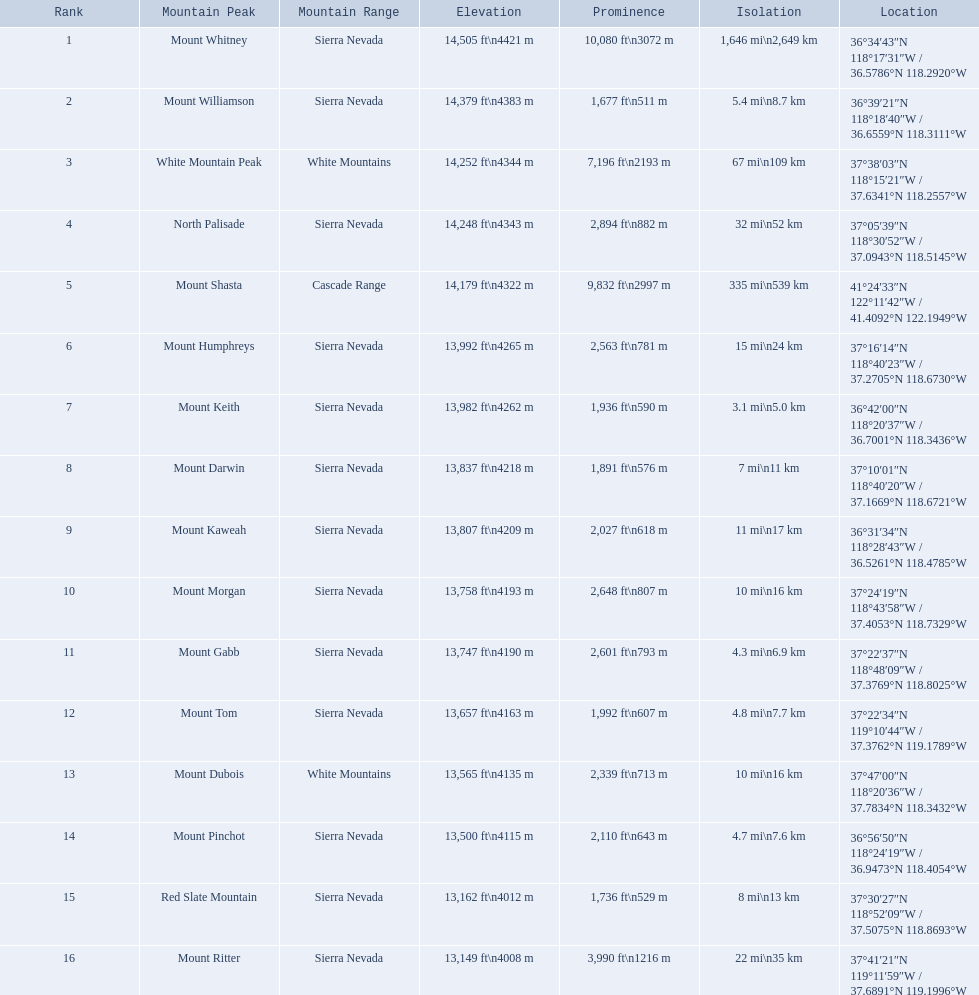What is the height of various mountain peaks in california? 14,505 ft\n4421 m, 14,379 ft\n4383 m, 14,252 ft\n4344 m, 14,248 ft\n4343 m, 14,179 ft\n4322 m, 13,992 ft\n4265 m, 13,982 ft\n4262 m, 13,837 ft\n4218 m, 13,807 ft\n4209 m, 13,758 ft\n4193 m, 13,747 ft\n4190 m, 13,657 ft\n4163 m, 13,565 ft\n4135 m, 13,500 ft\n4115 m, 13,162 ft\n4012 m, 13,149 ft\n4008 m. Is there a peak with an elevation of 13,149 feet or less? 13,149 ft\n4008 m. What is the name of this mountain peak? Mount Ritter. What are the elevations of california's mountain peaks? 14,505 ft\n4421 m, 14,379 ft\n4383 m, 14,252 ft\n4344 m, 14,248 ft\n4343 m, 14,179 ft\n4322 m, 13,992 ft\n4265 m, 13,982 ft\n4262 m, 13,837 ft\n4218 m, 13,807 ft\n4209 m, 13,758 ft\n4193 m, 13,747 ft\n4190 m, 13,657 ft\n4163 m, 13,565 ft\n4135 m, 13,500 ft\n4115 m, 13,162 ft\n4012 m, 13,149 ft\n4008 m. Can you identify a peak with a height of 13,149 feet or below? 13,149 ft\n4008 m. What is the mountain peak with this elevation called? Mount Ritter. What are the provided elevations? 14,505 ft\n4421 m, 14,379 ft\n4383 m, 14,252 ft\n4344 m, 14,248 ft\n4343 m, 14,179 ft\n4322 m, 13,992 ft\n4265 m, 13,982 ft\n4262 m, 13,837 ft\n4218 m, 13,807 ft\n4209 m, 13,758 ft\n4193 m, 13,747 ft\n4190 m, 13,657 ft\n4163 m, 13,565 ft\n4135 m, 13,500 ft\n4115 m, 13,162 ft\n4012 m, 13,149 ft\n4008 m. Which one is at or below 13,149 feet? 13,149 ft\n4008 m. To which mountain summit does this height belong? Mount Ritter. 